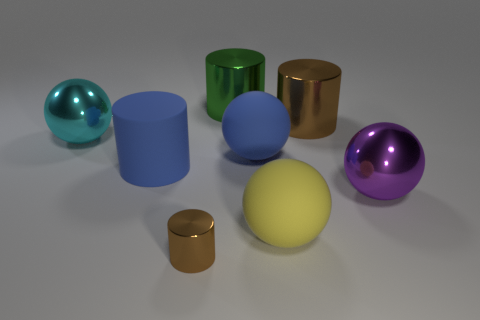Add 1 large yellow objects. How many objects exist? 9 Subtract all green cylinders. How many cylinders are left? 3 Subtract all large purple shiny spheres. How many spheres are left? 3 Subtract 1 cylinders. How many cylinders are left? 3 Subtract all red cylinders. Subtract all yellow spheres. How many cylinders are left? 4 Subtract all cyan cylinders. How many brown spheres are left? 0 Subtract all big spheres. Subtract all large yellow balls. How many objects are left? 3 Add 7 large cylinders. How many large cylinders are left? 10 Add 7 tiny yellow matte balls. How many tiny yellow matte balls exist? 7 Subtract 0 green cubes. How many objects are left? 8 